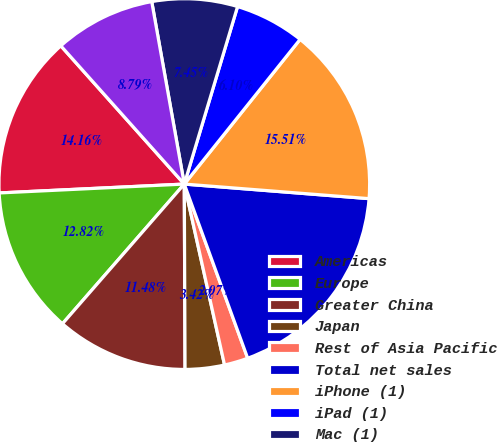Convert chart to OTSL. <chart><loc_0><loc_0><loc_500><loc_500><pie_chart><fcel>Americas<fcel>Europe<fcel>Greater China<fcel>Japan<fcel>Rest of Asia Pacific<fcel>Total net sales<fcel>iPhone (1)<fcel>iPad (1)<fcel>Mac (1)<fcel>Services (2)<nl><fcel>14.16%<fcel>12.82%<fcel>11.48%<fcel>3.42%<fcel>2.07%<fcel>18.19%<fcel>15.51%<fcel>6.1%<fcel>7.45%<fcel>8.79%<nl></chart> 